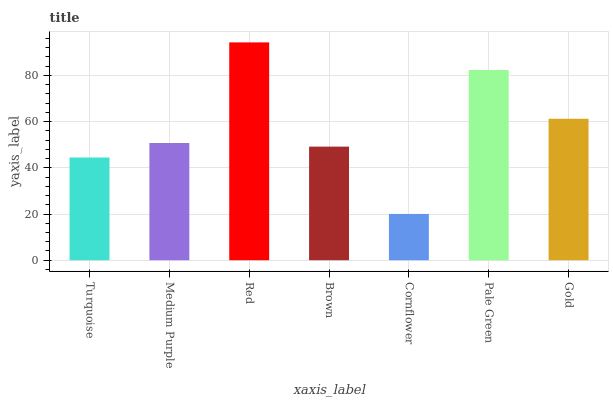Is Cornflower the minimum?
Answer yes or no. Yes. Is Red the maximum?
Answer yes or no. Yes. Is Medium Purple the minimum?
Answer yes or no. No. Is Medium Purple the maximum?
Answer yes or no. No. Is Medium Purple greater than Turquoise?
Answer yes or no. Yes. Is Turquoise less than Medium Purple?
Answer yes or no. Yes. Is Turquoise greater than Medium Purple?
Answer yes or no. No. Is Medium Purple less than Turquoise?
Answer yes or no. No. Is Medium Purple the high median?
Answer yes or no. Yes. Is Medium Purple the low median?
Answer yes or no. Yes. Is Brown the high median?
Answer yes or no. No. Is Cornflower the low median?
Answer yes or no. No. 